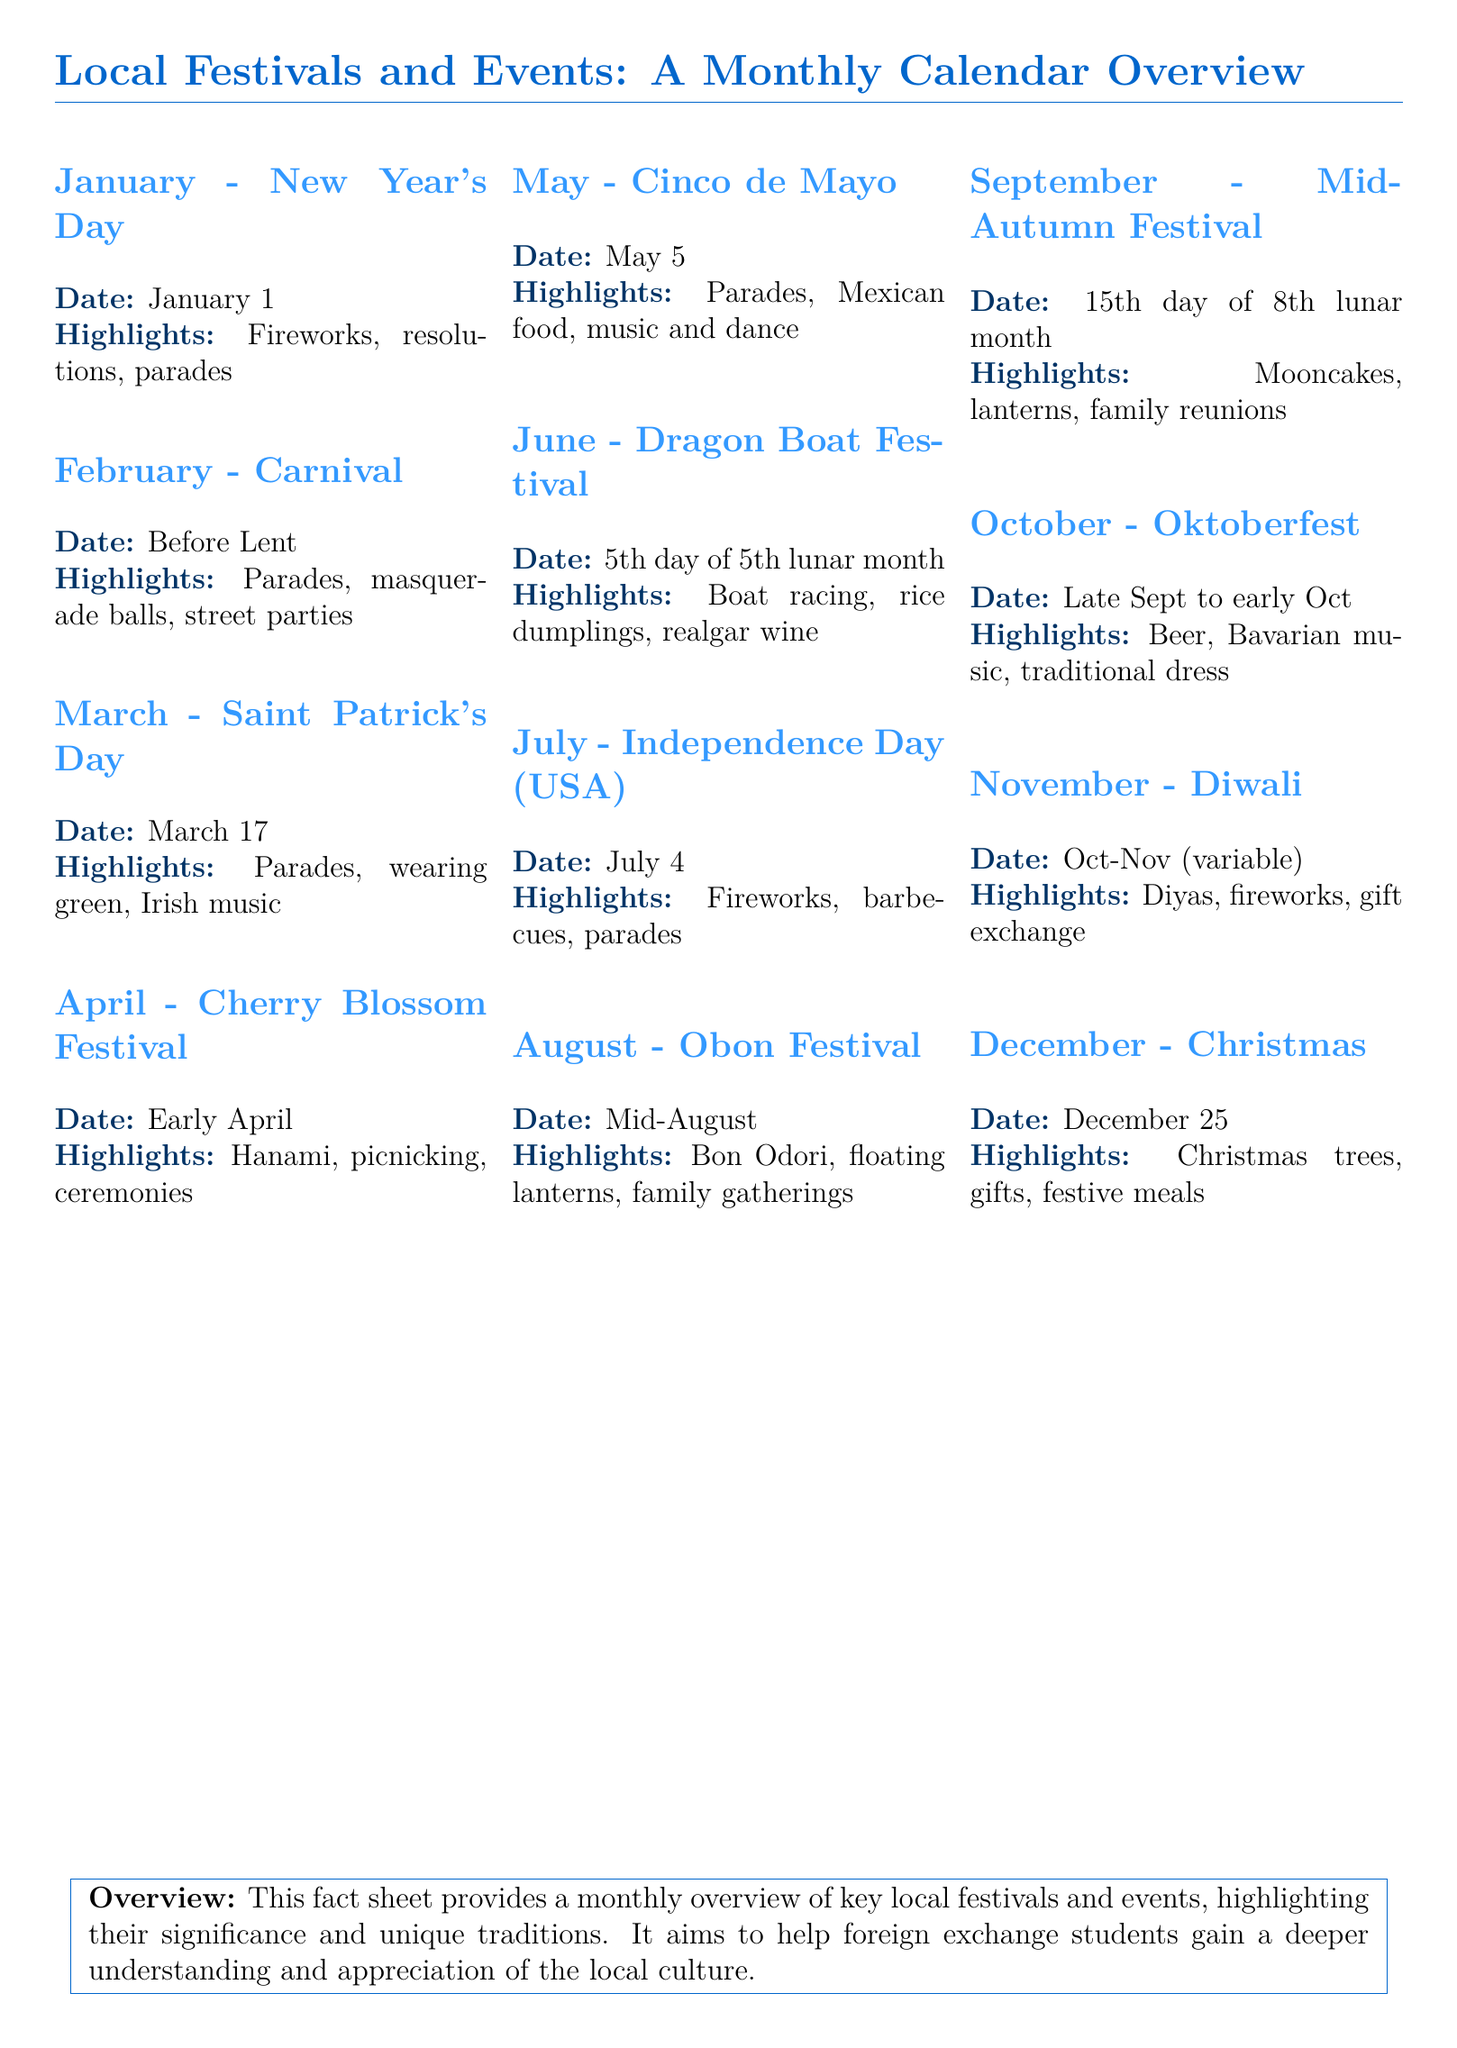What is the date of New Year's Day? The document states that New Year's Day is on January 1.
Answer: January 1 What highlights are associated with Carnival? The document lists parades, masquerade balls, and street parties as highlights of Carnival.
Answer: Parades, masquerade balls, street parties Which festival includes boat racing? The Dragon Boat Festival is the event mentioned in the document that includes boat racing.
Answer: Dragon Boat Festival What month does Diwali fall in? According to the document, Diwali occurs in October to November, but the exact date is variable.
Answer: Oct-Nov (variable) What tradition is celebrated during the Mid-Autumn Festival? The document mentions mooncakes as a tradition celebrated during the Mid-Autumn Festival.
Answer: Mooncakes How many highlights are listed for Independence Day? The document lists three highlights for Independence Day: fireworks, barbecues, and parades.
Answer: Three What is the significance of the Cherry Blossom Festival? The Cherry Blossom Festival is significant for Hanami, picnicking, and ceremonies as per the document.
Answer: Hanami, picnicking, ceremonies Which festival involves a floating lantern ceremony? The Obon Festival involves a floating lantern ceremony, as stated in the document.
Answer: Obon Festival What type of document is this? The document is a fact sheet providing a monthly overview of local festivals and events.
Answer: Fact sheet 